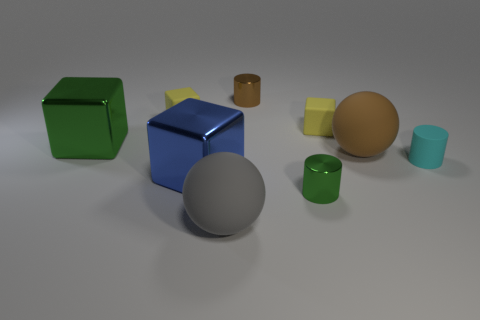Subtract all green cubes. How many cubes are left? 3 Subtract 1 blocks. How many blocks are left? 3 Subtract all yellow cubes. How many brown cylinders are left? 1 Subtract all small yellow matte cubes. Subtract all gray things. How many objects are left? 6 Add 9 green cylinders. How many green cylinders are left? 10 Add 6 tiny brown matte cylinders. How many tiny brown matte cylinders exist? 6 Subtract all green cylinders. How many cylinders are left? 2 Subtract 0 purple spheres. How many objects are left? 9 Subtract all balls. How many objects are left? 7 Subtract all gray cylinders. Subtract all purple cubes. How many cylinders are left? 3 